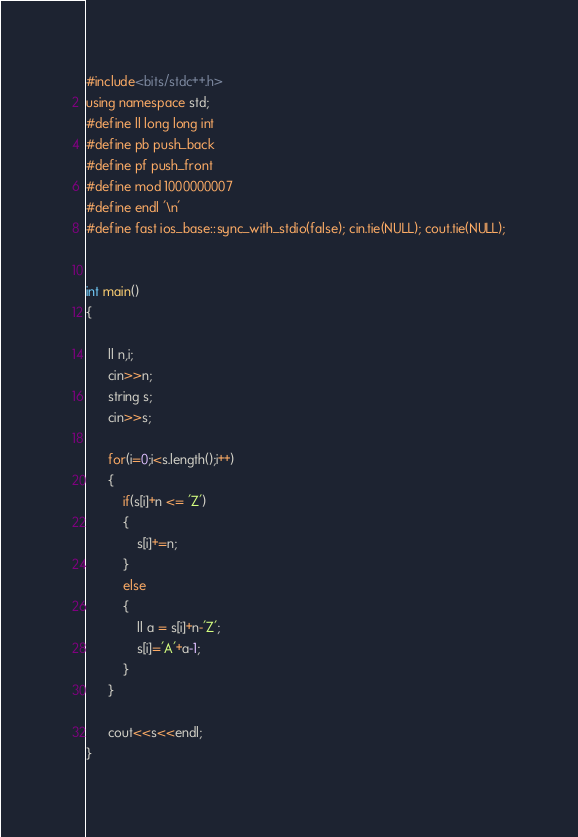Convert code to text. <code><loc_0><loc_0><loc_500><loc_500><_C++_>#include<bits/stdc++.h>
using namespace std;
#define ll long long int
#define pb push_back
#define pf push_front
#define mod 1000000007
#define endl '\n'
#define fast ios_base::sync_with_stdio(false); cin.tie(NULL); cout.tie(NULL);


int main()
{

      ll n,i;
      cin>>n;
      string s;
      cin>>s;

      for(i=0;i<s.length();i++)
      {
          if(s[i]+n <= 'Z')
          {
              s[i]+=n;
          }
          else
          {
              ll a = s[i]+n-'Z';
              s[i]='A'+a-1;
          }
      }

      cout<<s<<endl;
}
</code> 